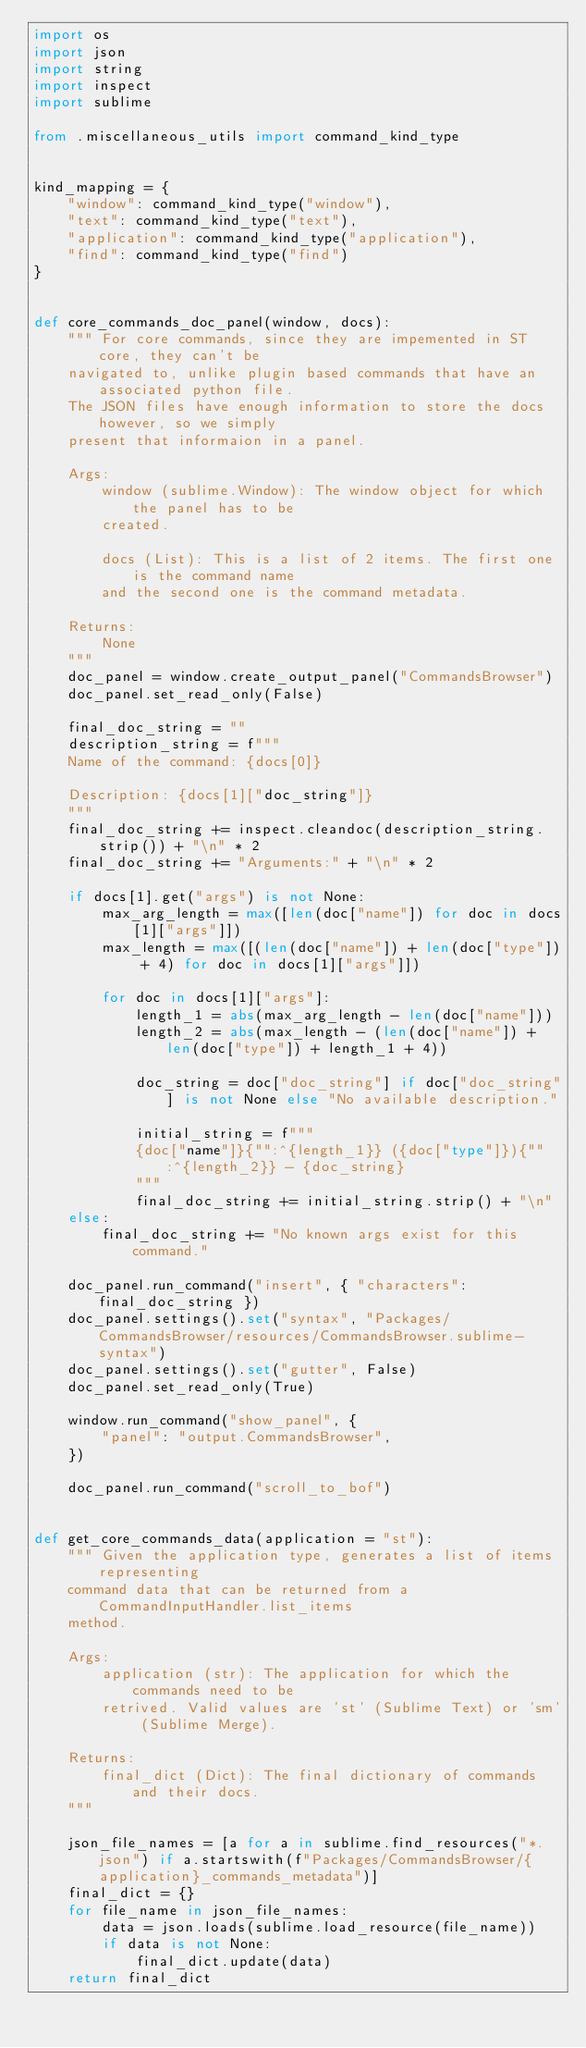Convert code to text. <code><loc_0><loc_0><loc_500><loc_500><_Python_>import os
import json
import string
import inspect
import sublime

from .miscellaneous_utils import command_kind_type


kind_mapping = {
    "window": command_kind_type("window"),
    "text": command_kind_type("text"),
    "application": command_kind_type("application"),
    "find": command_kind_type("find")
}


def core_commands_doc_panel(window, docs):
    """ For core commands, since they are impemented in ST core, they can't be
    navigated to, unlike plugin based commands that have an associated python file.
    The JSON files have enough information to store the docs however, so we simply
    present that informaion in a panel.

    Args:
        window (sublime.Window): The window object for which the panel has to be
        created.

        docs (List): This is a list of 2 items. The first one is the command name
        and the second one is the command metadata.

    Returns:
        None
    """
    doc_panel = window.create_output_panel("CommandsBrowser")
    doc_panel.set_read_only(False)

    final_doc_string = ""
    description_string = f"""
    Name of the command: {docs[0]}

    Description: {docs[1]["doc_string"]}
    """
    final_doc_string += inspect.cleandoc(description_string.strip()) + "\n" * 2
    final_doc_string += "Arguments:" + "\n" * 2

    if docs[1].get("args") is not None:
        max_arg_length = max([len(doc["name"]) for doc in docs[1]["args"]])
        max_length = max([(len(doc["name"]) + len(doc["type"]) + 4) for doc in docs[1]["args"]])

        for doc in docs[1]["args"]:
            length_1 = abs(max_arg_length - len(doc["name"]))
            length_2 = abs(max_length - (len(doc["name"]) + len(doc["type"]) + length_1 + 4))

            doc_string = doc["doc_string"] if doc["doc_string"] is not None else "No available description."

            initial_string = f"""
            {doc["name"]}{"":^{length_1}} ({doc["type"]}){"":^{length_2}} - {doc_string}
            """
            final_doc_string += initial_string.strip() + "\n"
    else:
        final_doc_string += "No known args exist for this command."

    doc_panel.run_command("insert", { "characters": final_doc_string })
    doc_panel.settings().set("syntax", "Packages/CommandsBrowser/resources/CommandsBrowser.sublime-syntax")
    doc_panel.settings().set("gutter", False)
    doc_panel.set_read_only(True)

    window.run_command("show_panel", {
        "panel": "output.CommandsBrowser",
    })

    doc_panel.run_command("scroll_to_bof")


def get_core_commands_data(application = "st"):
    """ Given the application type, generates a list of items representing
    command data that can be returned from a CommandInputHandler.list_items
    method.

    Args:
        application (str): The application for which the commands need to be
        retrived. Valid values are 'st' (Sublime Text) or 'sm' (Sublime Merge).

    Returns:
        final_dict (Dict): The final dictionary of commands and their docs.
    """

    json_file_names = [a for a in sublime.find_resources("*.json") if a.startswith(f"Packages/CommandsBrowser/{application}_commands_metadata")]
    final_dict = {}
    for file_name in json_file_names:
        data = json.loads(sublime.load_resource(file_name))
        if data is not None:
            final_dict.update(data)
    return final_dict
</code> 